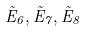Convert formula to latex. <formula><loc_0><loc_0><loc_500><loc_500>\tilde { E } _ { 6 } , \tilde { E } _ { 7 } , \tilde { E } _ { 8 }</formula> 